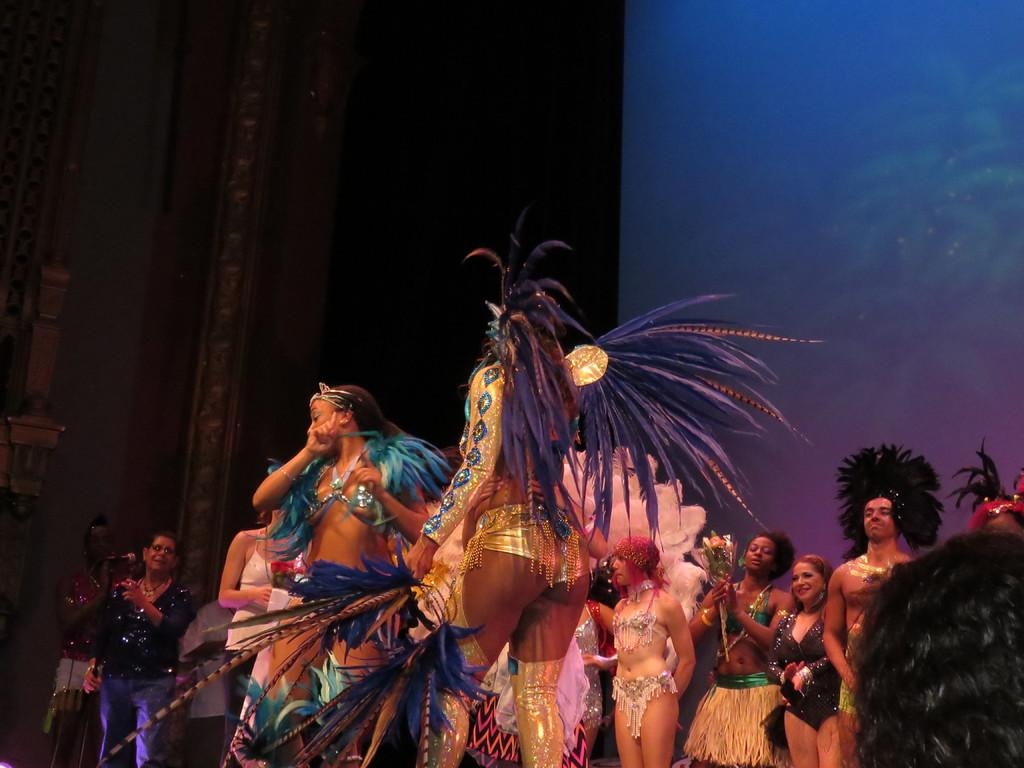What is the main subject of the image? The main subject of the image is a group of girls. What are the girls wearing in the image? The girls are wearing fancy dresses in the image. What are the girls doing in the image? The girls are dancing on a stage in the image. What can be seen in the background of the image? There is a black curtain and a blue wall in the background of the image. What type of pets are the girls taking care of in the image? There are no pets present in the image; the girls are dancing on a stage. How many kittens can be seen playing with the girls in the image? There are no kittens present in the image; the girls are wearing fancy dresses and dancing on a stage. 